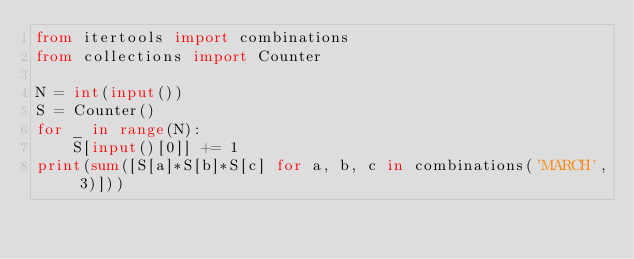Convert code to text. <code><loc_0><loc_0><loc_500><loc_500><_Python_>from itertools import combinations
from collections import Counter

N = int(input())
S = Counter()
for _ in range(N):
    S[input()[0]] += 1
print(sum([S[a]*S[b]*S[c] for a, b, c in combinations('MARCH', 3)]))
</code> 